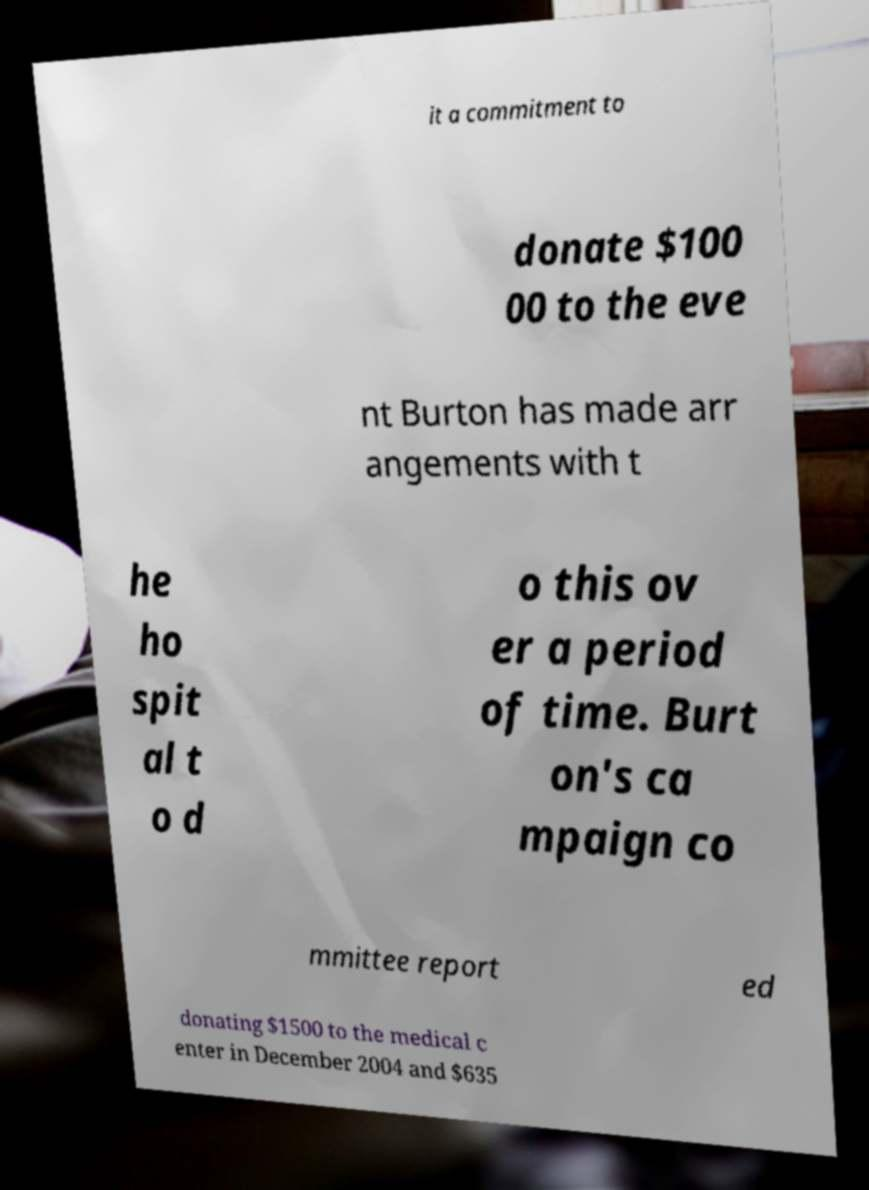I need the written content from this picture converted into text. Can you do that? it a commitment to donate $100 00 to the eve nt Burton has made arr angements with t he ho spit al t o d o this ov er a period of time. Burt on's ca mpaign co mmittee report ed donating $1500 to the medical c enter in December 2004 and $635 